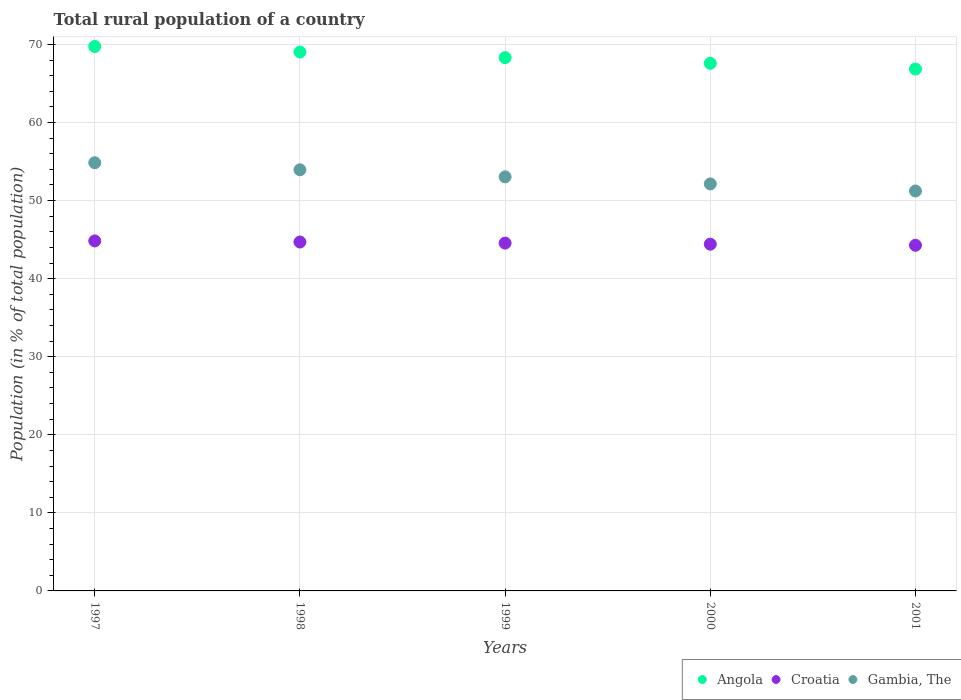How many different coloured dotlines are there?
Ensure brevity in your answer.  3. What is the rural population in Gambia, The in 1999?
Provide a short and direct response. 53.04. Across all years, what is the maximum rural population in Croatia?
Your answer should be compact. 44.83. Across all years, what is the minimum rural population in Angola?
Your response must be concise. 66.85. What is the total rural population in Angola in the graph?
Offer a terse response. 341.49. What is the difference between the rural population in Croatia in 1997 and that in 2001?
Provide a succinct answer. 0.55. What is the difference between the rural population in Angola in 1997 and the rural population in Gambia, The in 2001?
Your answer should be very brief. 18.51. What is the average rural population in Angola per year?
Your response must be concise. 68.3. In the year 1999, what is the difference between the rural population in Gambia, The and rural population in Croatia?
Offer a terse response. 8.49. What is the ratio of the rural population in Croatia in 1998 to that in 1999?
Offer a terse response. 1. Is the rural population in Croatia in 1998 less than that in 2000?
Make the answer very short. No. What is the difference between the highest and the second highest rural population in Angola?
Provide a short and direct response. 0.71. What is the difference between the highest and the lowest rural population in Angola?
Your answer should be compact. 2.88. In how many years, is the rural population in Croatia greater than the average rural population in Croatia taken over all years?
Your answer should be very brief. 2. How many dotlines are there?
Your answer should be compact. 3. How many years are there in the graph?
Offer a terse response. 5. Are the values on the major ticks of Y-axis written in scientific E-notation?
Give a very brief answer. No. Where does the legend appear in the graph?
Offer a terse response. Bottom right. How many legend labels are there?
Provide a short and direct response. 3. What is the title of the graph?
Offer a terse response. Total rural population of a country. Does "Cuba" appear as one of the legend labels in the graph?
Offer a terse response. No. What is the label or title of the Y-axis?
Ensure brevity in your answer.  Population (in % of total population). What is the Population (in % of total population) in Angola in 1997?
Your answer should be compact. 69.73. What is the Population (in % of total population) in Croatia in 1997?
Make the answer very short. 44.83. What is the Population (in % of total population) in Gambia, The in 1997?
Your response must be concise. 54.84. What is the Population (in % of total population) of Angola in 1998?
Make the answer very short. 69.03. What is the Population (in % of total population) in Croatia in 1998?
Provide a succinct answer. 44.69. What is the Population (in % of total population) in Gambia, The in 1998?
Ensure brevity in your answer.  53.94. What is the Population (in % of total population) of Angola in 1999?
Provide a short and direct response. 68.31. What is the Population (in % of total population) of Croatia in 1999?
Your answer should be very brief. 44.55. What is the Population (in % of total population) in Gambia, The in 1999?
Offer a very short reply. 53.04. What is the Population (in % of total population) of Angola in 2000?
Your answer should be compact. 67.58. What is the Population (in % of total population) in Croatia in 2000?
Provide a succinct answer. 44.41. What is the Population (in % of total population) in Gambia, The in 2000?
Make the answer very short. 52.13. What is the Population (in % of total population) of Angola in 2001?
Keep it short and to the point. 66.85. What is the Population (in % of total population) of Croatia in 2001?
Ensure brevity in your answer.  44.27. What is the Population (in % of total population) in Gambia, The in 2001?
Offer a very short reply. 51.23. Across all years, what is the maximum Population (in % of total population) of Angola?
Offer a terse response. 69.73. Across all years, what is the maximum Population (in % of total population) in Croatia?
Offer a very short reply. 44.83. Across all years, what is the maximum Population (in % of total population) of Gambia, The?
Make the answer very short. 54.84. Across all years, what is the minimum Population (in % of total population) of Angola?
Ensure brevity in your answer.  66.85. Across all years, what is the minimum Population (in % of total population) in Croatia?
Keep it short and to the point. 44.27. Across all years, what is the minimum Population (in % of total population) of Gambia, The?
Keep it short and to the point. 51.23. What is the total Population (in % of total population) in Angola in the graph?
Provide a short and direct response. 341.49. What is the total Population (in % of total population) of Croatia in the graph?
Your response must be concise. 222.76. What is the total Population (in % of total population) of Gambia, The in the graph?
Keep it short and to the point. 265.18. What is the difference between the Population (in % of total population) in Angola in 1997 and that in 1998?
Make the answer very short. 0.71. What is the difference between the Population (in % of total population) in Croatia in 1997 and that in 1998?
Keep it short and to the point. 0.14. What is the difference between the Population (in % of total population) in Gambia, The in 1997 and that in 1998?
Your answer should be compact. 0.9. What is the difference between the Population (in % of total population) of Angola in 1997 and that in 1999?
Keep it short and to the point. 1.42. What is the difference between the Population (in % of total population) in Croatia in 1997 and that in 1999?
Make the answer very short. 0.28. What is the difference between the Population (in % of total population) of Gambia, The in 1997 and that in 1999?
Your answer should be compact. 1.81. What is the difference between the Population (in % of total population) in Angola in 1997 and that in 2000?
Your answer should be compact. 2.15. What is the difference between the Population (in % of total population) of Croatia in 1997 and that in 2000?
Make the answer very short. 0.42. What is the difference between the Population (in % of total population) of Gambia, The in 1997 and that in 2000?
Offer a terse response. 2.71. What is the difference between the Population (in % of total population) in Angola in 1997 and that in 2001?
Your answer should be compact. 2.88. What is the difference between the Population (in % of total population) of Croatia in 1997 and that in 2001?
Your answer should be compact. 0.56. What is the difference between the Population (in % of total population) of Gambia, The in 1997 and that in 2001?
Provide a short and direct response. 3.62. What is the difference between the Population (in % of total population) in Angola in 1998 and that in 1999?
Offer a terse response. 0.72. What is the difference between the Population (in % of total population) of Croatia in 1998 and that in 1999?
Give a very brief answer. 0.14. What is the difference between the Population (in % of total population) in Gambia, The in 1998 and that in 1999?
Offer a very short reply. 0.9. What is the difference between the Population (in % of total population) in Angola in 1998 and that in 2000?
Offer a very short reply. 1.44. What is the difference between the Population (in % of total population) in Croatia in 1998 and that in 2000?
Offer a very short reply. 0.28. What is the difference between the Population (in % of total population) of Gambia, The in 1998 and that in 2000?
Provide a succinct answer. 1.81. What is the difference between the Population (in % of total population) in Angola in 1998 and that in 2001?
Give a very brief answer. 2.18. What is the difference between the Population (in % of total population) in Croatia in 1998 and that in 2001?
Make the answer very short. 0.42. What is the difference between the Population (in % of total population) of Gambia, The in 1998 and that in 2001?
Make the answer very short. 2.72. What is the difference between the Population (in % of total population) of Angola in 1999 and that in 2000?
Your answer should be very brief. 0.73. What is the difference between the Population (in % of total population) of Croatia in 1999 and that in 2000?
Offer a very short reply. 0.14. What is the difference between the Population (in % of total population) of Gambia, The in 1999 and that in 2000?
Give a very brief answer. 0.91. What is the difference between the Population (in % of total population) of Angola in 1999 and that in 2001?
Offer a very short reply. 1.46. What is the difference between the Population (in % of total population) of Croatia in 1999 and that in 2001?
Provide a short and direct response. 0.28. What is the difference between the Population (in % of total population) in Gambia, The in 1999 and that in 2001?
Your answer should be very brief. 1.81. What is the difference between the Population (in % of total population) of Angola in 2000 and that in 2001?
Provide a succinct answer. 0.73. What is the difference between the Population (in % of total population) of Croatia in 2000 and that in 2001?
Provide a succinct answer. 0.14. What is the difference between the Population (in % of total population) of Gambia, The in 2000 and that in 2001?
Offer a terse response. 0.91. What is the difference between the Population (in % of total population) of Angola in 1997 and the Population (in % of total population) of Croatia in 1998?
Make the answer very short. 25.04. What is the difference between the Population (in % of total population) of Angola in 1997 and the Population (in % of total population) of Gambia, The in 1998?
Your answer should be very brief. 15.79. What is the difference between the Population (in % of total population) in Croatia in 1997 and the Population (in % of total population) in Gambia, The in 1998?
Keep it short and to the point. -9.11. What is the difference between the Population (in % of total population) in Angola in 1997 and the Population (in % of total population) in Croatia in 1999?
Offer a very short reply. 25.18. What is the difference between the Population (in % of total population) of Angola in 1997 and the Population (in % of total population) of Gambia, The in 1999?
Provide a short and direct response. 16.69. What is the difference between the Population (in % of total population) of Croatia in 1997 and the Population (in % of total population) of Gambia, The in 1999?
Your answer should be very brief. -8.21. What is the difference between the Population (in % of total population) of Angola in 1997 and the Population (in % of total population) of Croatia in 2000?
Ensure brevity in your answer.  25.32. What is the difference between the Population (in % of total population) in Angola in 1997 and the Population (in % of total population) in Gambia, The in 2000?
Your answer should be compact. 17.6. What is the difference between the Population (in % of total population) in Croatia in 1997 and the Population (in % of total population) in Gambia, The in 2000?
Your response must be concise. -7.3. What is the difference between the Population (in % of total population) of Angola in 1997 and the Population (in % of total population) of Croatia in 2001?
Ensure brevity in your answer.  25.46. What is the difference between the Population (in % of total population) in Angola in 1997 and the Population (in % of total population) in Gambia, The in 2001?
Give a very brief answer. 18.51. What is the difference between the Population (in % of total population) of Croatia in 1997 and the Population (in % of total population) of Gambia, The in 2001?
Your response must be concise. -6.39. What is the difference between the Population (in % of total population) of Angola in 1998 and the Population (in % of total population) of Croatia in 1999?
Provide a succinct answer. 24.47. What is the difference between the Population (in % of total population) in Angola in 1998 and the Population (in % of total population) in Gambia, The in 1999?
Your answer should be very brief. 15.99. What is the difference between the Population (in % of total population) in Croatia in 1998 and the Population (in % of total population) in Gambia, The in 1999?
Give a very brief answer. -8.35. What is the difference between the Population (in % of total population) of Angola in 1998 and the Population (in % of total population) of Croatia in 2000?
Provide a succinct answer. 24.61. What is the difference between the Population (in % of total population) of Angola in 1998 and the Population (in % of total population) of Gambia, The in 2000?
Offer a very short reply. 16.89. What is the difference between the Population (in % of total population) of Croatia in 1998 and the Population (in % of total population) of Gambia, The in 2000?
Keep it short and to the point. -7.44. What is the difference between the Population (in % of total population) of Angola in 1998 and the Population (in % of total population) of Croatia in 2001?
Make the answer very short. 24.75. What is the difference between the Population (in % of total population) of Angola in 1998 and the Population (in % of total population) of Gambia, The in 2001?
Your response must be concise. 17.8. What is the difference between the Population (in % of total population) in Croatia in 1998 and the Population (in % of total population) in Gambia, The in 2001?
Ensure brevity in your answer.  -6.53. What is the difference between the Population (in % of total population) of Angola in 1999 and the Population (in % of total population) of Croatia in 2000?
Your answer should be compact. 23.89. What is the difference between the Population (in % of total population) in Angola in 1999 and the Population (in % of total population) in Gambia, The in 2000?
Give a very brief answer. 16.18. What is the difference between the Population (in % of total population) of Croatia in 1999 and the Population (in % of total population) of Gambia, The in 2000?
Offer a very short reply. -7.58. What is the difference between the Population (in % of total population) in Angola in 1999 and the Population (in % of total population) in Croatia in 2001?
Keep it short and to the point. 24.03. What is the difference between the Population (in % of total population) of Angola in 1999 and the Population (in % of total population) of Gambia, The in 2001?
Make the answer very short. 17.08. What is the difference between the Population (in % of total population) of Croatia in 1999 and the Population (in % of total population) of Gambia, The in 2001?
Provide a succinct answer. -6.67. What is the difference between the Population (in % of total population) in Angola in 2000 and the Population (in % of total population) in Croatia in 2001?
Provide a short and direct response. 23.31. What is the difference between the Population (in % of total population) in Angola in 2000 and the Population (in % of total population) in Gambia, The in 2001?
Give a very brief answer. 16.36. What is the difference between the Population (in % of total population) of Croatia in 2000 and the Population (in % of total population) of Gambia, The in 2001?
Your answer should be compact. -6.81. What is the average Population (in % of total population) of Angola per year?
Your response must be concise. 68.3. What is the average Population (in % of total population) in Croatia per year?
Your response must be concise. 44.55. What is the average Population (in % of total population) of Gambia, The per year?
Provide a succinct answer. 53.04. In the year 1997, what is the difference between the Population (in % of total population) in Angola and Population (in % of total population) in Croatia?
Make the answer very short. 24.9. In the year 1997, what is the difference between the Population (in % of total population) of Angola and Population (in % of total population) of Gambia, The?
Give a very brief answer. 14.89. In the year 1997, what is the difference between the Population (in % of total population) of Croatia and Population (in % of total population) of Gambia, The?
Your answer should be very brief. -10.02. In the year 1998, what is the difference between the Population (in % of total population) in Angola and Population (in % of total population) in Croatia?
Your response must be concise. 24.33. In the year 1998, what is the difference between the Population (in % of total population) of Angola and Population (in % of total population) of Gambia, The?
Provide a short and direct response. 15.08. In the year 1998, what is the difference between the Population (in % of total population) in Croatia and Population (in % of total population) in Gambia, The?
Make the answer very short. -9.25. In the year 1999, what is the difference between the Population (in % of total population) of Angola and Population (in % of total population) of Croatia?
Give a very brief answer. 23.76. In the year 1999, what is the difference between the Population (in % of total population) in Angola and Population (in % of total population) in Gambia, The?
Offer a very short reply. 15.27. In the year 1999, what is the difference between the Population (in % of total population) of Croatia and Population (in % of total population) of Gambia, The?
Keep it short and to the point. -8.49. In the year 2000, what is the difference between the Population (in % of total population) in Angola and Population (in % of total population) in Croatia?
Ensure brevity in your answer.  23.17. In the year 2000, what is the difference between the Population (in % of total population) of Angola and Population (in % of total population) of Gambia, The?
Keep it short and to the point. 15.45. In the year 2000, what is the difference between the Population (in % of total population) in Croatia and Population (in % of total population) in Gambia, The?
Provide a short and direct response. -7.72. In the year 2001, what is the difference between the Population (in % of total population) of Angola and Population (in % of total population) of Croatia?
Ensure brevity in your answer.  22.57. In the year 2001, what is the difference between the Population (in % of total population) of Angola and Population (in % of total population) of Gambia, The?
Provide a succinct answer. 15.62. In the year 2001, what is the difference between the Population (in % of total population) of Croatia and Population (in % of total population) of Gambia, The?
Your response must be concise. -6.95. What is the ratio of the Population (in % of total population) in Angola in 1997 to that in 1998?
Offer a terse response. 1.01. What is the ratio of the Population (in % of total population) of Croatia in 1997 to that in 1998?
Your response must be concise. 1. What is the ratio of the Population (in % of total population) in Gambia, The in 1997 to that in 1998?
Ensure brevity in your answer.  1.02. What is the ratio of the Population (in % of total population) in Angola in 1997 to that in 1999?
Give a very brief answer. 1.02. What is the ratio of the Population (in % of total population) in Gambia, The in 1997 to that in 1999?
Offer a terse response. 1.03. What is the ratio of the Population (in % of total population) of Angola in 1997 to that in 2000?
Give a very brief answer. 1.03. What is the ratio of the Population (in % of total population) of Croatia in 1997 to that in 2000?
Offer a terse response. 1.01. What is the ratio of the Population (in % of total population) of Gambia, The in 1997 to that in 2000?
Ensure brevity in your answer.  1.05. What is the ratio of the Population (in % of total population) in Angola in 1997 to that in 2001?
Your answer should be very brief. 1.04. What is the ratio of the Population (in % of total population) in Croatia in 1997 to that in 2001?
Give a very brief answer. 1.01. What is the ratio of the Population (in % of total population) in Gambia, The in 1997 to that in 2001?
Give a very brief answer. 1.07. What is the ratio of the Population (in % of total population) of Angola in 1998 to that in 1999?
Provide a short and direct response. 1.01. What is the ratio of the Population (in % of total population) in Gambia, The in 1998 to that in 1999?
Your answer should be compact. 1.02. What is the ratio of the Population (in % of total population) in Angola in 1998 to that in 2000?
Offer a terse response. 1.02. What is the ratio of the Population (in % of total population) in Croatia in 1998 to that in 2000?
Your answer should be very brief. 1.01. What is the ratio of the Population (in % of total population) in Gambia, The in 1998 to that in 2000?
Your response must be concise. 1.03. What is the ratio of the Population (in % of total population) in Angola in 1998 to that in 2001?
Provide a succinct answer. 1.03. What is the ratio of the Population (in % of total population) of Croatia in 1998 to that in 2001?
Offer a very short reply. 1.01. What is the ratio of the Population (in % of total population) of Gambia, The in 1998 to that in 2001?
Your answer should be compact. 1.05. What is the ratio of the Population (in % of total population) of Angola in 1999 to that in 2000?
Your answer should be very brief. 1.01. What is the ratio of the Population (in % of total population) in Croatia in 1999 to that in 2000?
Your answer should be very brief. 1. What is the ratio of the Population (in % of total population) of Gambia, The in 1999 to that in 2000?
Make the answer very short. 1.02. What is the ratio of the Population (in % of total population) in Angola in 1999 to that in 2001?
Your answer should be very brief. 1.02. What is the ratio of the Population (in % of total population) of Gambia, The in 1999 to that in 2001?
Keep it short and to the point. 1.04. What is the ratio of the Population (in % of total population) in Angola in 2000 to that in 2001?
Give a very brief answer. 1.01. What is the ratio of the Population (in % of total population) in Gambia, The in 2000 to that in 2001?
Provide a short and direct response. 1.02. What is the difference between the highest and the second highest Population (in % of total population) in Angola?
Provide a succinct answer. 0.71. What is the difference between the highest and the second highest Population (in % of total population) of Croatia?
Your answer should be compact. 0.14. What is the difference between the highest and the second highest Population (in % of total population) in Gambia, The?
Offer a very short reply. 0.9. What is the difference between the highest and the lowest Population (in % of total population) in Angola?
Provide a short and direct response. 2.88. What is the difference between the highest and the lowest Population (in % of total population) of Croatia?
Your response must be concise. 0.56. What is the difference between the highest and the lowest Population (in % of total population) in Gambia, The?
Give a very brief answer. 3.62. 